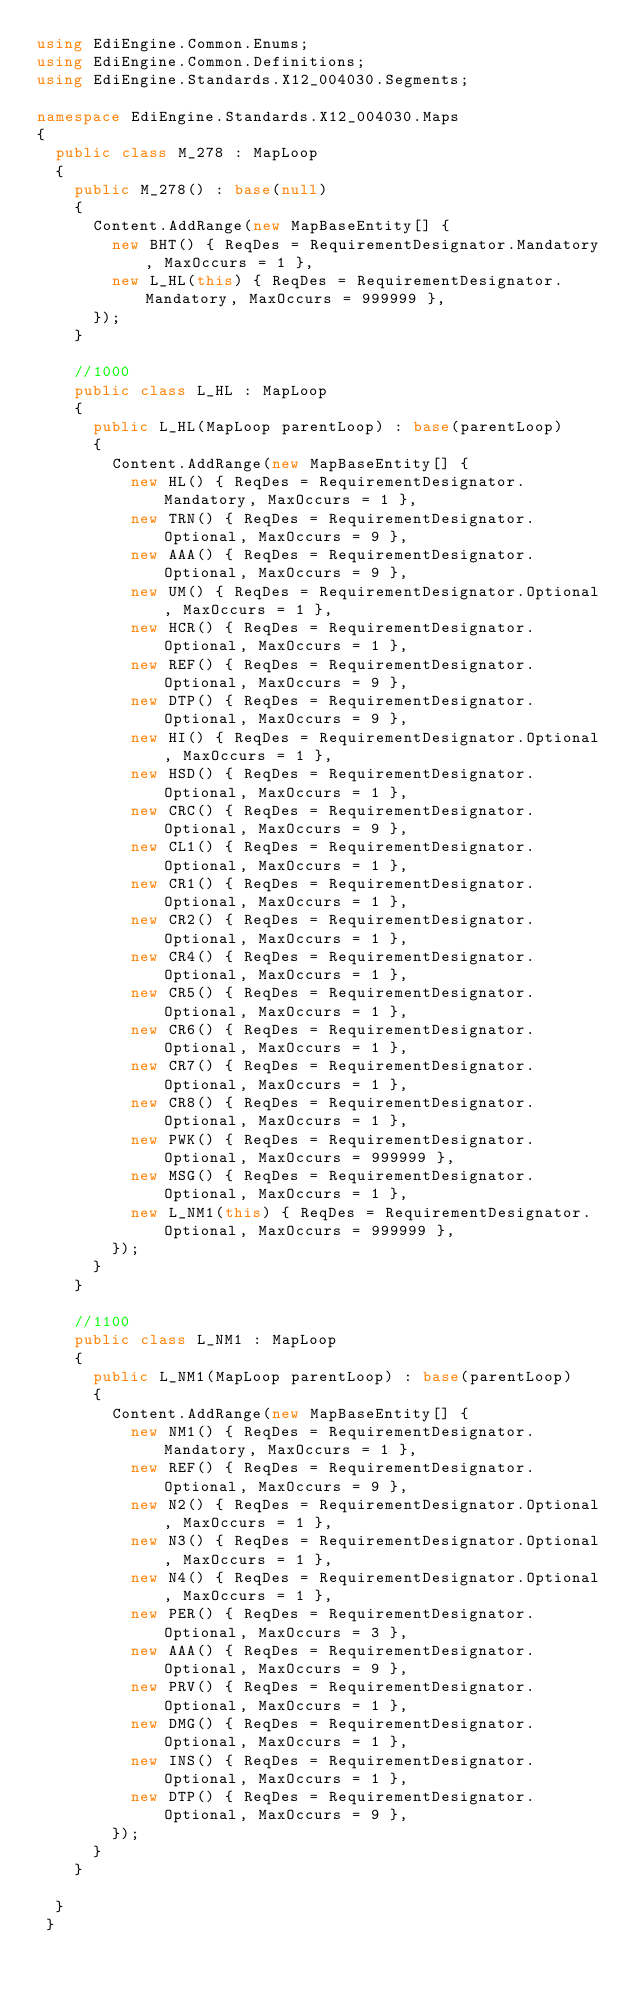<code> <loc_0><loc_0><loc_500><loc_500><_C#_>using EdiEngine.Common.Enums;
using EdiEngine.Common.Definitions;
using EdiEngine.Standards.X12_004030.Segments;

namespace EdiEngine.Standards.X12_004030.Maps
{
	public class M_278 : MapLoop
	{
		public M_278() : base(null)
		{
			Content.AddRange(new MapBaseEntity[] {
				new BHT() { ReqDes = RequirementDesignator.Mandatory, MaxOccurs = 1 },
				new L_HL(this) { ReqDes = RequirementDesignator.Mandatory, MaxOccurs = 999999 },
			});
		}

		//1000
		public class L_HL : MapLoop
		{
			public L_HL(MapLoop parentLoop) : base(parentLoop)
			{
				Content.AddRange(new MapBaseEntity[] {
					new HL() { ReqDes = RequirementDesignator.Mandatory, MaxOccurs = 1 },
					new TRN() { ReqDes = RequirementDesignator.Optional, MaxOccurs = 9 },
					new AAA() { ReqDes = RequirementDesignator.Optional, MaxOccurs = 9 },
					new UM() { ReqDes = RequirementDesignator.Optional, MaxOccurs = 1 },
					new HCR() { ReqDes = RequirementDesignator.Optional, MaxOccurs = 1 },
					new REF() { ReqDes = RequirementDesignator.Optional, MaxOccurs = 9 },
					new DTP() { ReqDes = RequirementDesignator.Optional, MaxOccurs = 9 },
					new HI() { ReqDes = RequirementDesignator.Optional, MaxOccurs = 1 },
					new HSD() { ReqDes = RequirementDesignator.Optional, MaxOccurs = 1 },
					new CRC() { ReqDes = RequirementDesignator.Optional, MaxOccurs = 9 },
					new CL1() { ReqDes = RequirementDesignator.Optional, MaxOccurs = 1 },
					new CR1() { ReqDes = RequirementDesignator.Optional, MaxOccurs = 1 },
					new CR2() { ReqDes = RequirementDesignator.Optional, MaxOccurs = 1 },
					new CR4() { ReqDes = RequirementDesignator.Optional, MaxOccurs = 1 },
					new CR5() { ReqDes = RequirementDesignator.Optional, MaxOccurs = 1 },
					new CR6() { ReqDes = RequirementDesignator.Optional, MaxOccurs = 1 },
					new CR7() { ReqDes = RequirementDesignator.Optional, MaxOccurs = 1 },
					new CR8() { ReqDes = RequirementDesignator.Optional, MaxOccurs = 1 },
					new PWK() { ReqDes = RequirementDesignator.Optional, MaxOccurs = 999999 },
					new MSG() { ReqDes = RequirementDesignator.Optional, MaxOccurs = 1 },
					new L_NM1(this) { ReqDes = RequirementDesignator.Optional, MaxOccurs = 999999 },
				});
			}
		}

		//1100
		public class L_NM1 : MapLoop
		{
			public L_NM1(MapLoop parentLoop) : base(parentLoop)
			{
				Content.AddRange(new MapBaseEntity[] {
					new NM1() { ReqDes = RequirementDesignator.Mandatory, MaxOccurs = 1 },
					new REF() { ReqDes = RequirementDesignator.Optional, MaxOccurs = 9 },
					new N2() { ReqDes = RequirementDesignator.Optional, MaxOccurs = 1 },
					new N3() { ReqDes = RequirementDesignator.Optional, MaxOccurs = 1 },
					new N4() { ReqDes = RequirementDesignator.Optional, MaxOccurs = 1 },
					new PER() { ReqDes = RequirementDesignator.Optional, MaxOccurs = 3 },
					new AAA() { ReqDes = RequirementDesignator.Optional, MaxOccurs = 9 },
					new PRV() { ReqDes = RequirementDesignator.Optional, MaxOccurs = 1 },
					new DMG() { ReqDes = RequirementDesignator.Optional, MaxOccurs = 1 },
					new INS() { ReqDes = RequirementDesignator.Optional, MaxOccurs = 1 },
					new DTP() { ReqDes = RequirementDesignator.Optional, MaxOccurs = 9 },
				});
			}
		}

	}
 }

</code> 